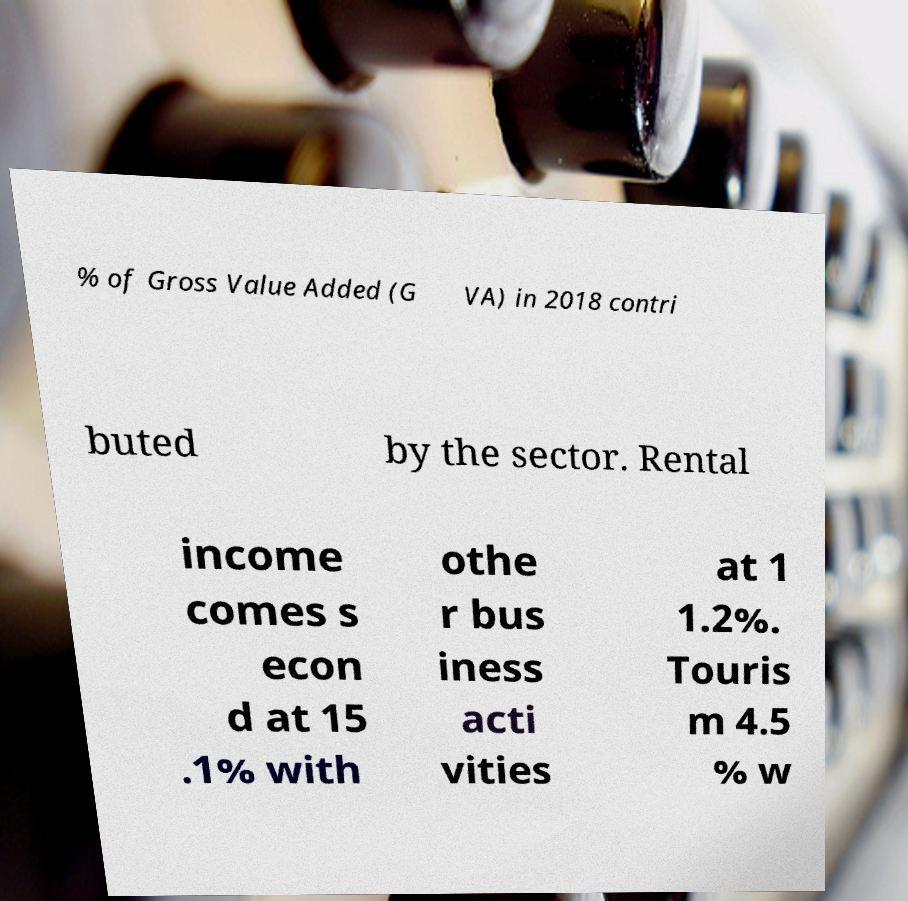Please read and relay the text visible in this image. What does it say? % of Gross Value Added (G VA) in 2018 contri buted by the sector. Rental income comes s econ d at 15 .1% with othe r bus iness acti vities at 1 1.2%. Touris m 4.5 % w 